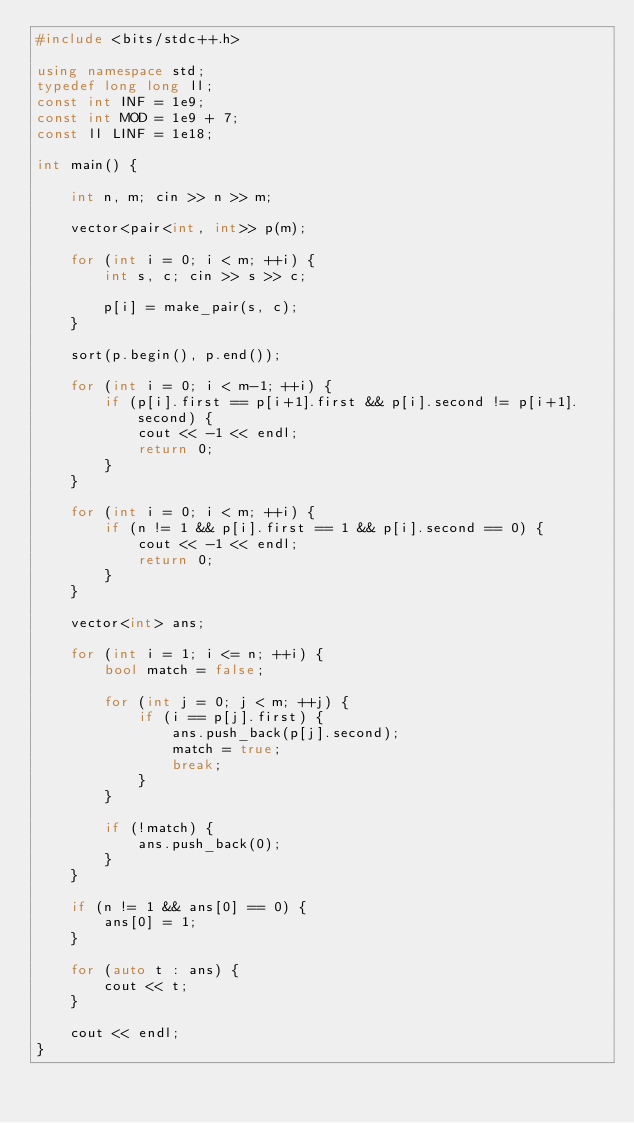<code> <loc_0><loc_0><loc_500><loc_500><_C++_>#include <bits/stdc++.h>

using namespace std;
typedef long long ll;
const int INF = 1e9;
const int MOD = 1e9 + 7;
const ll LINF = 1e18;

int main() {

    int n, m; cin >> n >> m;

    vector<pair<int, int>> p(m);

    for (int i = 0; i < m; ++i) {
        int s, c; cin >> s >> c;

        p[i] = make_pair(s, c);
    }

    sort(p.begin(), p.end());

    for (int i = 0; i < m-1; ++i) {
        if (p[i].first == p[i+1].first && p[i].second != p[i+1].second) {
            cout << -1 << endl;
            return 0;
        }
    }

    for (int i = 0; i < m; ++i) {
        if (n != 1 && p[i].first == 1 && p[i].second == 0) {
            cout << -1 << endl;
            return 0;
        }
    }

    vector<int> ans;

    for (int i = 1; i <= n; ++i) {
        bool match = false;

        for (int j = 0; j < m; ++j) {
            if (i == p[j].first) {
                ans.push_back(p[j].second);
                match = true;
                break;
            }
        }

        if (!match) {
            ans.push_back(0);
        }
    }

    if (n != 1 && ans[0] == 0) {
        ans[0] = 1;
    }

    for (auto t : ans) {
        cout << t;
    }

    cout << endl;
}</code> 